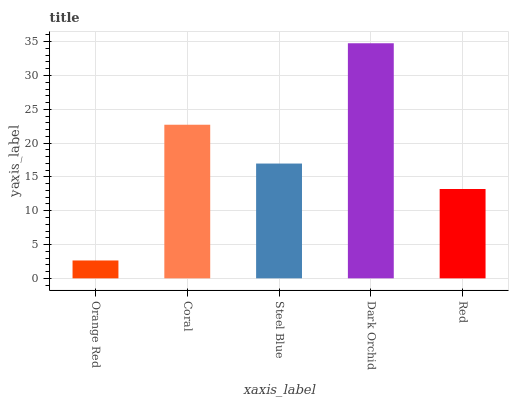Is Orange Red the minimum?
Answer yes or no. Yes. Is Dark Orchid the maximum?
Answer yes or no. Yes. Is Coral the minimum?
Answer yes or no. No. Is Coral the maximum?
Answer yes or no. No. Is Coral greater than Orange Red?
Answer yes or no. Yes. Is Orange Red less than Coral?
Answer yes or no. Yes. Is Orange Red greater than Coral?
Answer yes or no. No. Is Coral less than Orange Red?
Answer yes or no. No. Is Steel Blue the high median?
Answer yes or no. Yes. Is Steel Blue the low median?
Answer yes or no. Yes. Is Orange Red the high median?
Answer yes or no. No. Is Coral the low median?
Answer yes or no. No. 